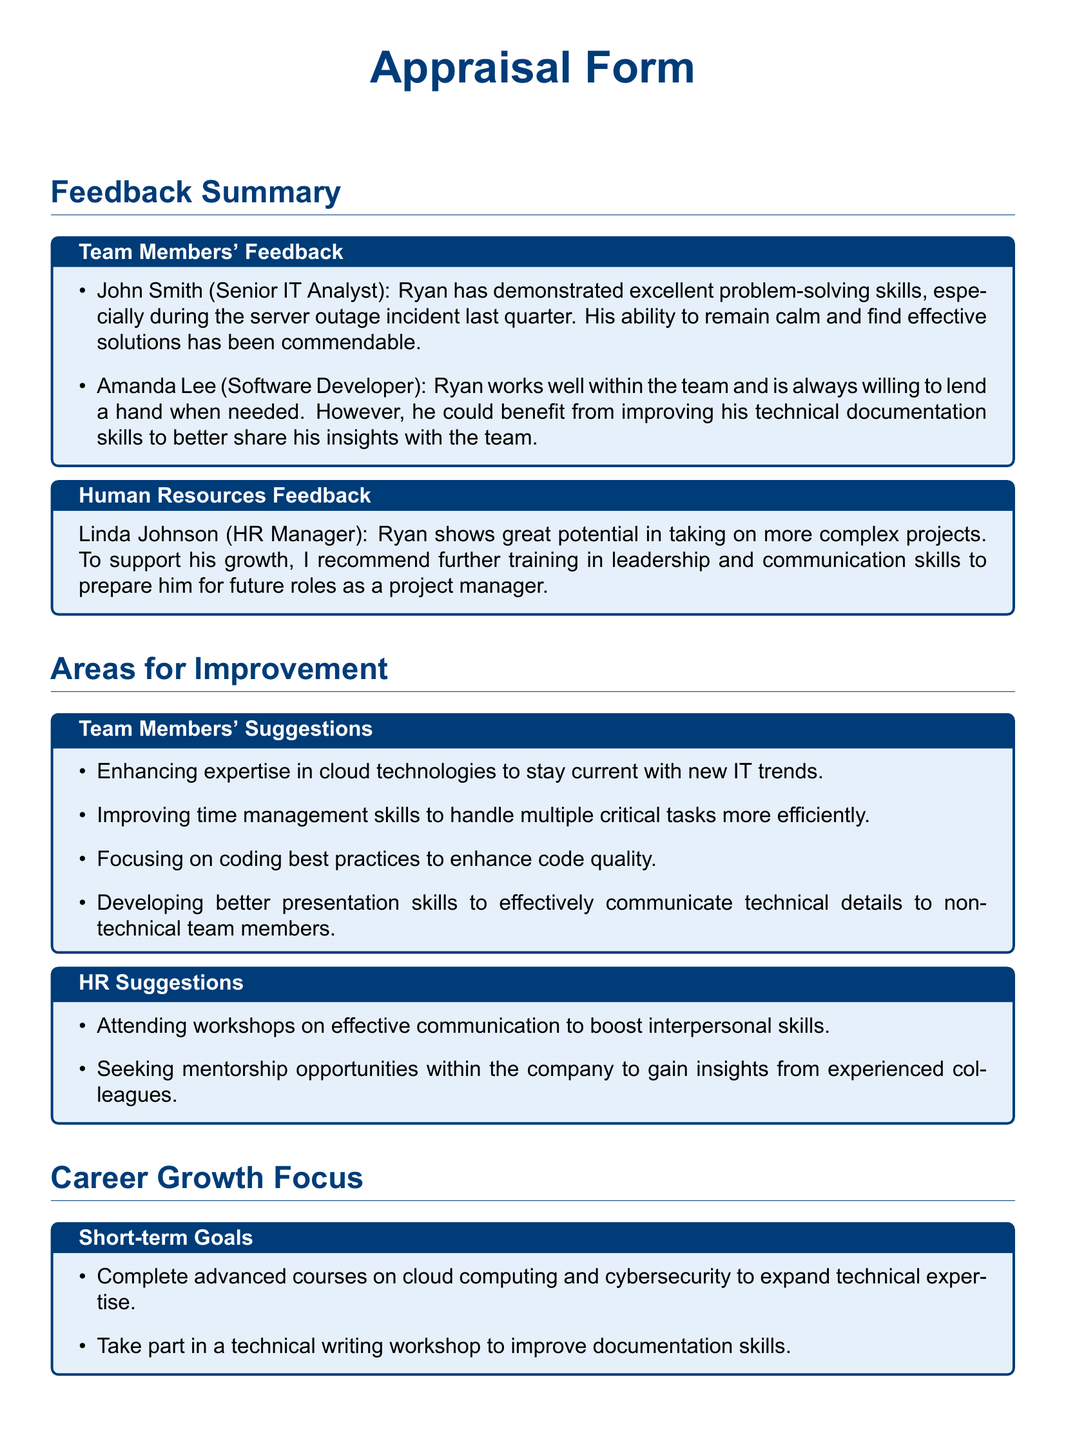what skills did Ryan demonstrate during the server outage? The feedback from John Smith states that Ryan has demonstrated excellent problem-solving skills during the server outage incident.
Answer: problem-solving skills who provided feedback about Ryan's need for improvement in technical documentation? Amanda Lee, the Software Developer, highlighted Ryan's need for improving his technical documentation skills.
Answer: Amanda Lee what is one suggestion from Human Resources for Ryan's growth? Linda Johnson from HR recommended further training in leadership and communication skills.
Answer: training in leadership and communication skills what is a suggested area for improvement from team members? The areas for improvement include enhancing expertise in cloud technologies to stay current with new IT trends.
Answer: cloud technologies what is one short-term goal Ryan should focus on? One short-term goal listed is to complete advanced courses on cloud computing and cybersecurity.
Answer: advanced courses on cloud computing and cybersecurity who is suggested to be a mentor for Ryan? HR suggests seeking mentorship opportunities within the company to gain insights from experienced colleagues.
Answer: experienced colleagues what is a long-term goal for Ryan's career growth? A long-term goal mentioned is to prepare for a project management certification.
Answer: project management certification how can Ryan improve his presentation skills? The document suggests developing better presentation skills to effectively communicate technical details.
Answer: better presentation skills what is a recommended workshop Ryan should attend? One recommendation from HR is to attend workshops on effective communication.
Answer: workshops on effective communication 